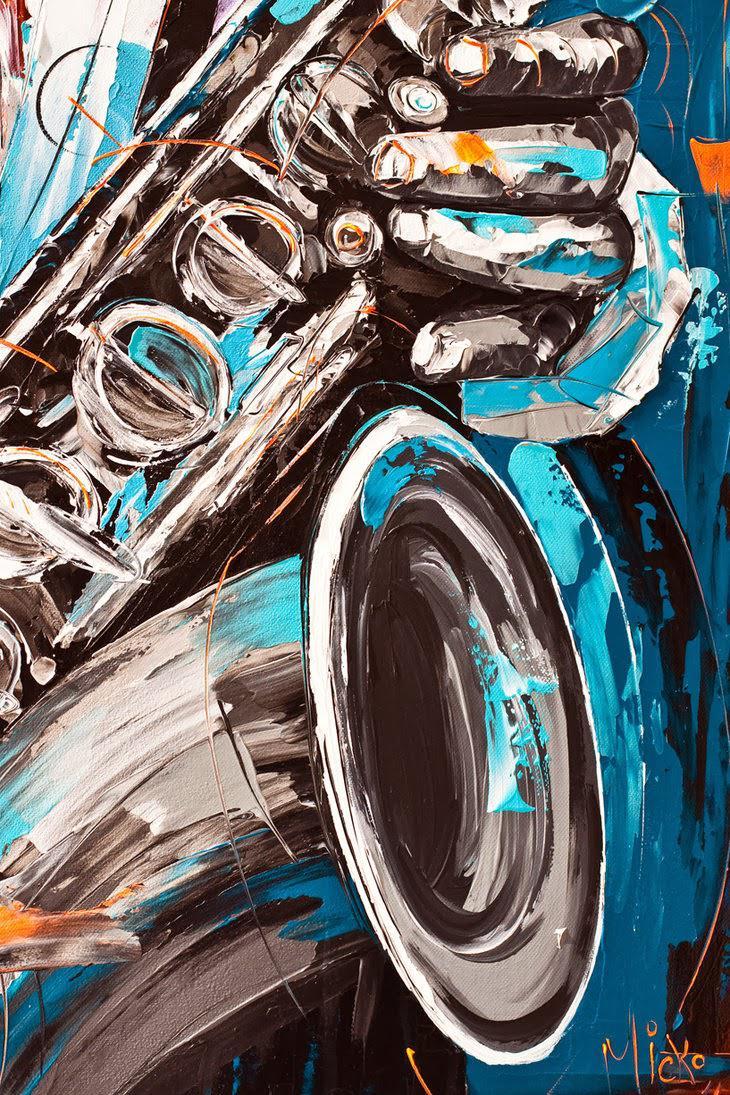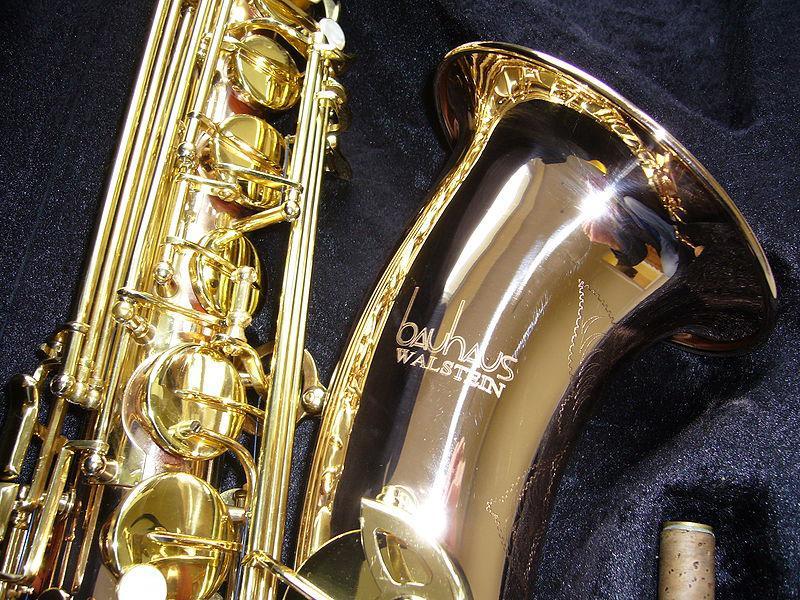The first image is the image on the left, the second image is the image on the right. Assess this claim about the two images: "One image is in color, while the other is a black and white photo of a person holding a saxophone.". Correct or not? Answer yes or no. No. The first image is the image on the left, the second image is the image on the right. Considering the images on both sides, is "One of the images contains a grouping of at least five saxophones, oriented in a variety of positions." valid? Answer yes or no. No. 